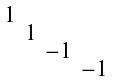Convert formula to latex. <formula><loc_0><loc_0><loc_500><loc_500>\begin{smallmatrix} 1 & & & \\ & 1 & & \\ & & - 1 & \\ & & & - 1 \end{smallmatrix}</formula> 